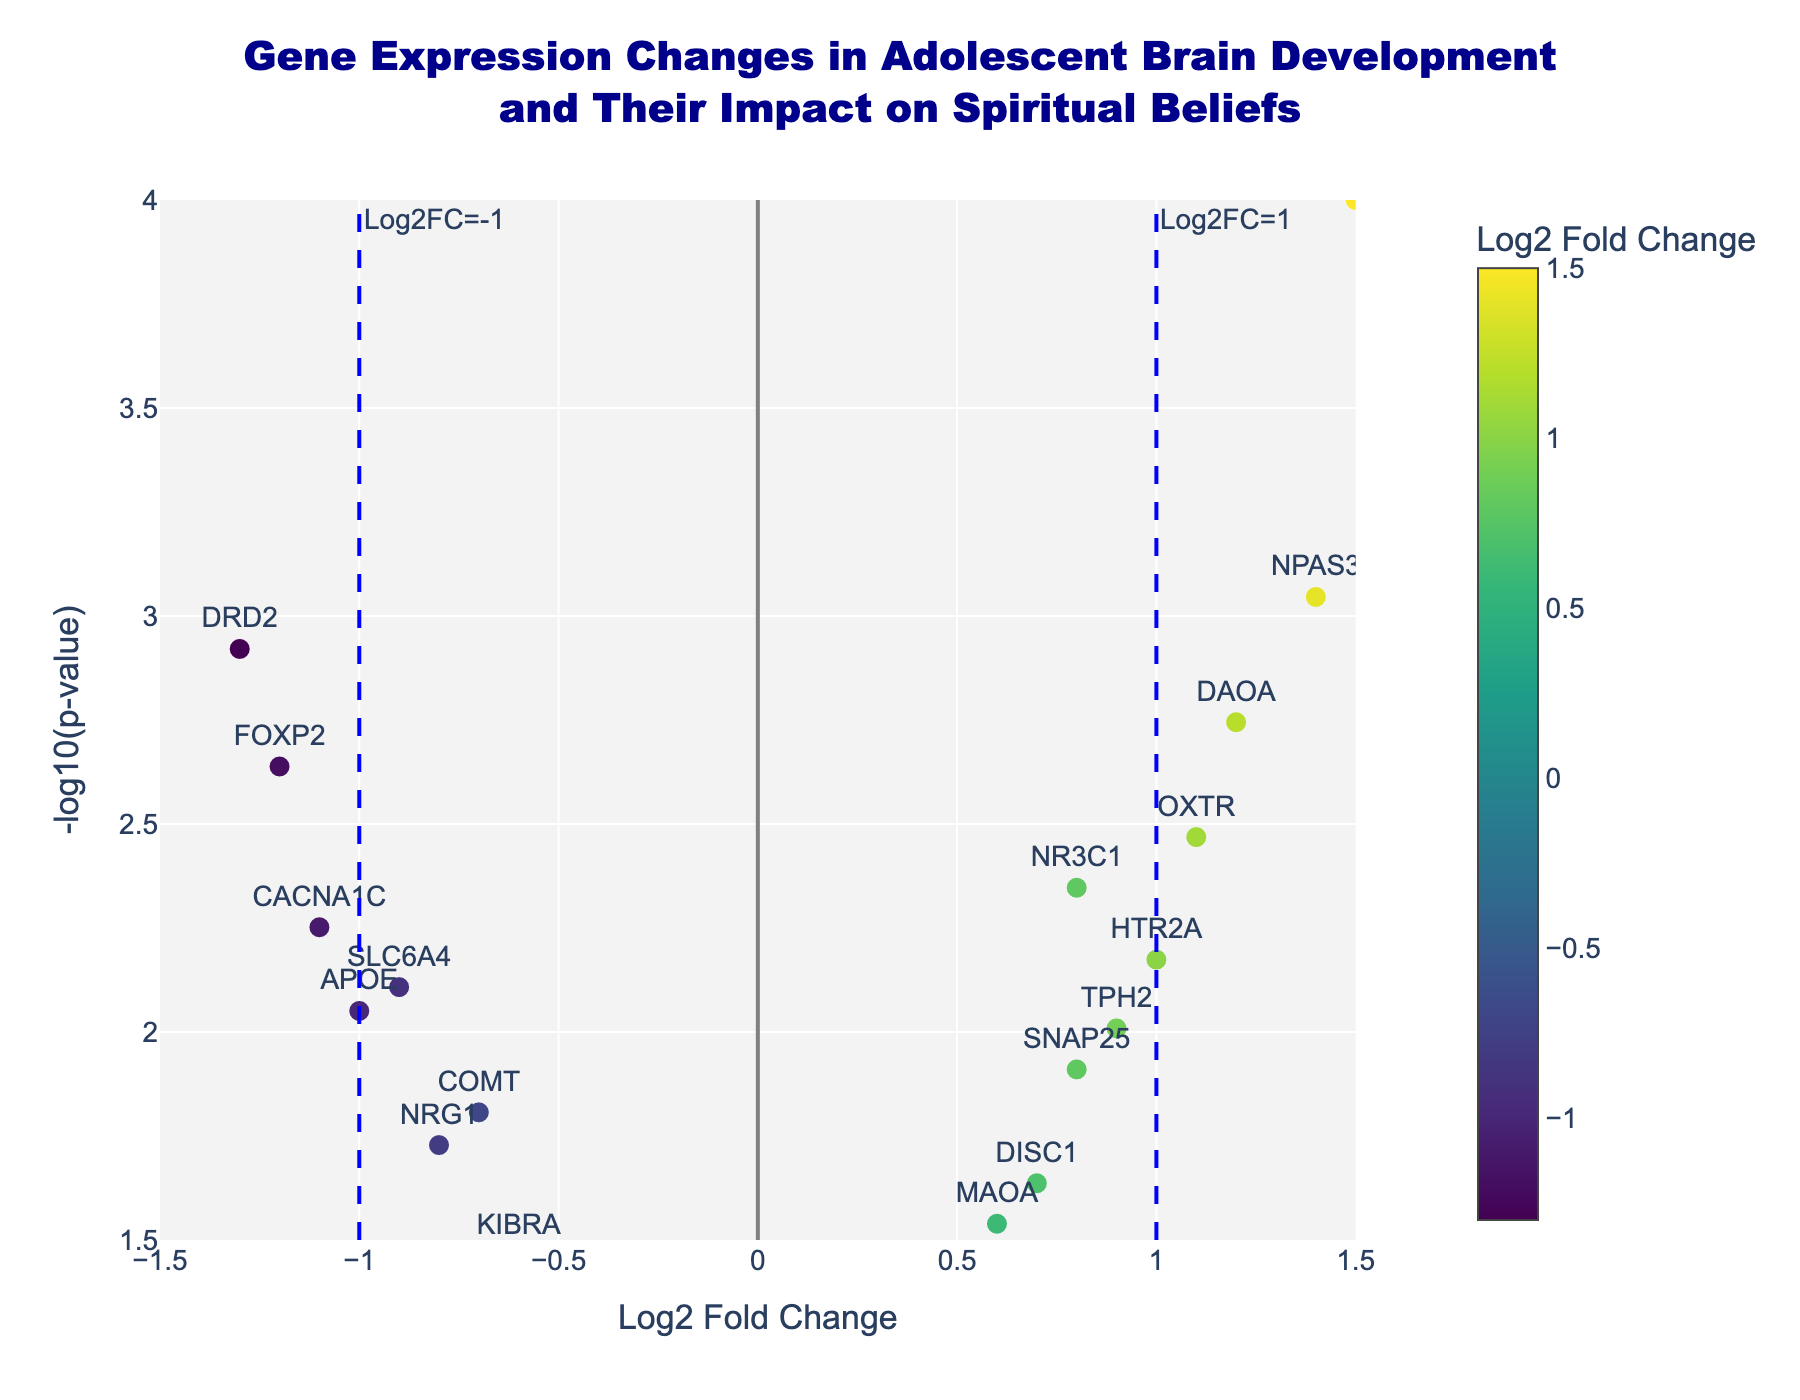What's the title of the Volcano Plot? The title is displayed at the very top of the plot. It reads "Gene Expression Changes in Adolescent Brain Development and Their Impact on Spiritual Beliefs".
Answer: "Gene Expression Changes in Adolescent Brain Development and Their Impact on Spiritual Beliefs" What does the red dashed horizontal line represent? The red dashed horizontal line is positioned at y = -log10(0.05), which signifies the p-value threshold of 0.05 for significance.
Answer: p=0.05 How many genes have a Log2 Fold Change greater than 1? Look at the x-axis where Log2 Fold Change is greater than 1. Count the data points in this region. There are 4 genes in this category: BDNF, OXTR, NPAS3, and DAOA.
Answer: 4 Which gene has the highest -log10(p-value)? Identify the data point that is the highest on the y-axis. The gene "BDNF" has the highest -log10(p-value).
Answer: BDNF How many genes are downregulated (negative Log2 Fold Change)? Count the number of data points located on the left side of the y-axis (where Log2 Fold Change < 0). There are 9 genes with negative Log2 Fold Change.
Answer: 9 Which gene has the smallest p-value, and what is its Log2 Fold Change? The gene with the smallest p-value will have the highest -log10(p-value). "BDNF" has the smallest p-value with a Log2 Fold Change of 1.5.
Answer: BDNF with Log2 Fold Change of 1.5 What is the range of Log2 Fold Change values on the x-axis? The x-axis range is given as from -1.5 to 1.5, as the axes are bounded in that interval.
Answer: -1.5 to 1.5 Which genes are within the top right and top left quadrants of the plot? The top right quadrant (positive Log2 Fold Change and high -log10(p-value)) contains BDNF, OXTR, NPAS3, DAOA. The top left quadrant (negative Log2 Fold Change and high -log10(p-value)) contains FOXP2, DRD2, CACNA1C, APOE.
Answer: Top right: BDNF, OXTR, NPAS3, DAOA; Top left: FOXP2, DRD2, CACNA1C, APOE 